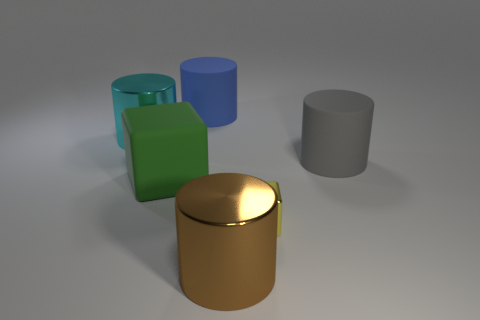Subtract all blue rubber cylinders. How many cylinders are left? 3 Subtract 1 cylinders. How many cylinders are left? 3 Subtract all brown cylinders. How many cylinders are left? 3 Add 2 small cubes. How many objects exist? 8 Subtract all blocks. How many objects are left? 4 Subtract all gray cylinders. Subtract all cyan spheres. How many cylinders are left? 3 Subtract all tiny red spheres. Subtract all green blocks. How many objects are left? 5 Add 6 cyan cylinders. How many cyan cylinders are left? 7 Add 6 small blue matte cubes. How many small blue matte cubes exist? 6 Subtract 1 gray cylinders. How many objects are left? 5 